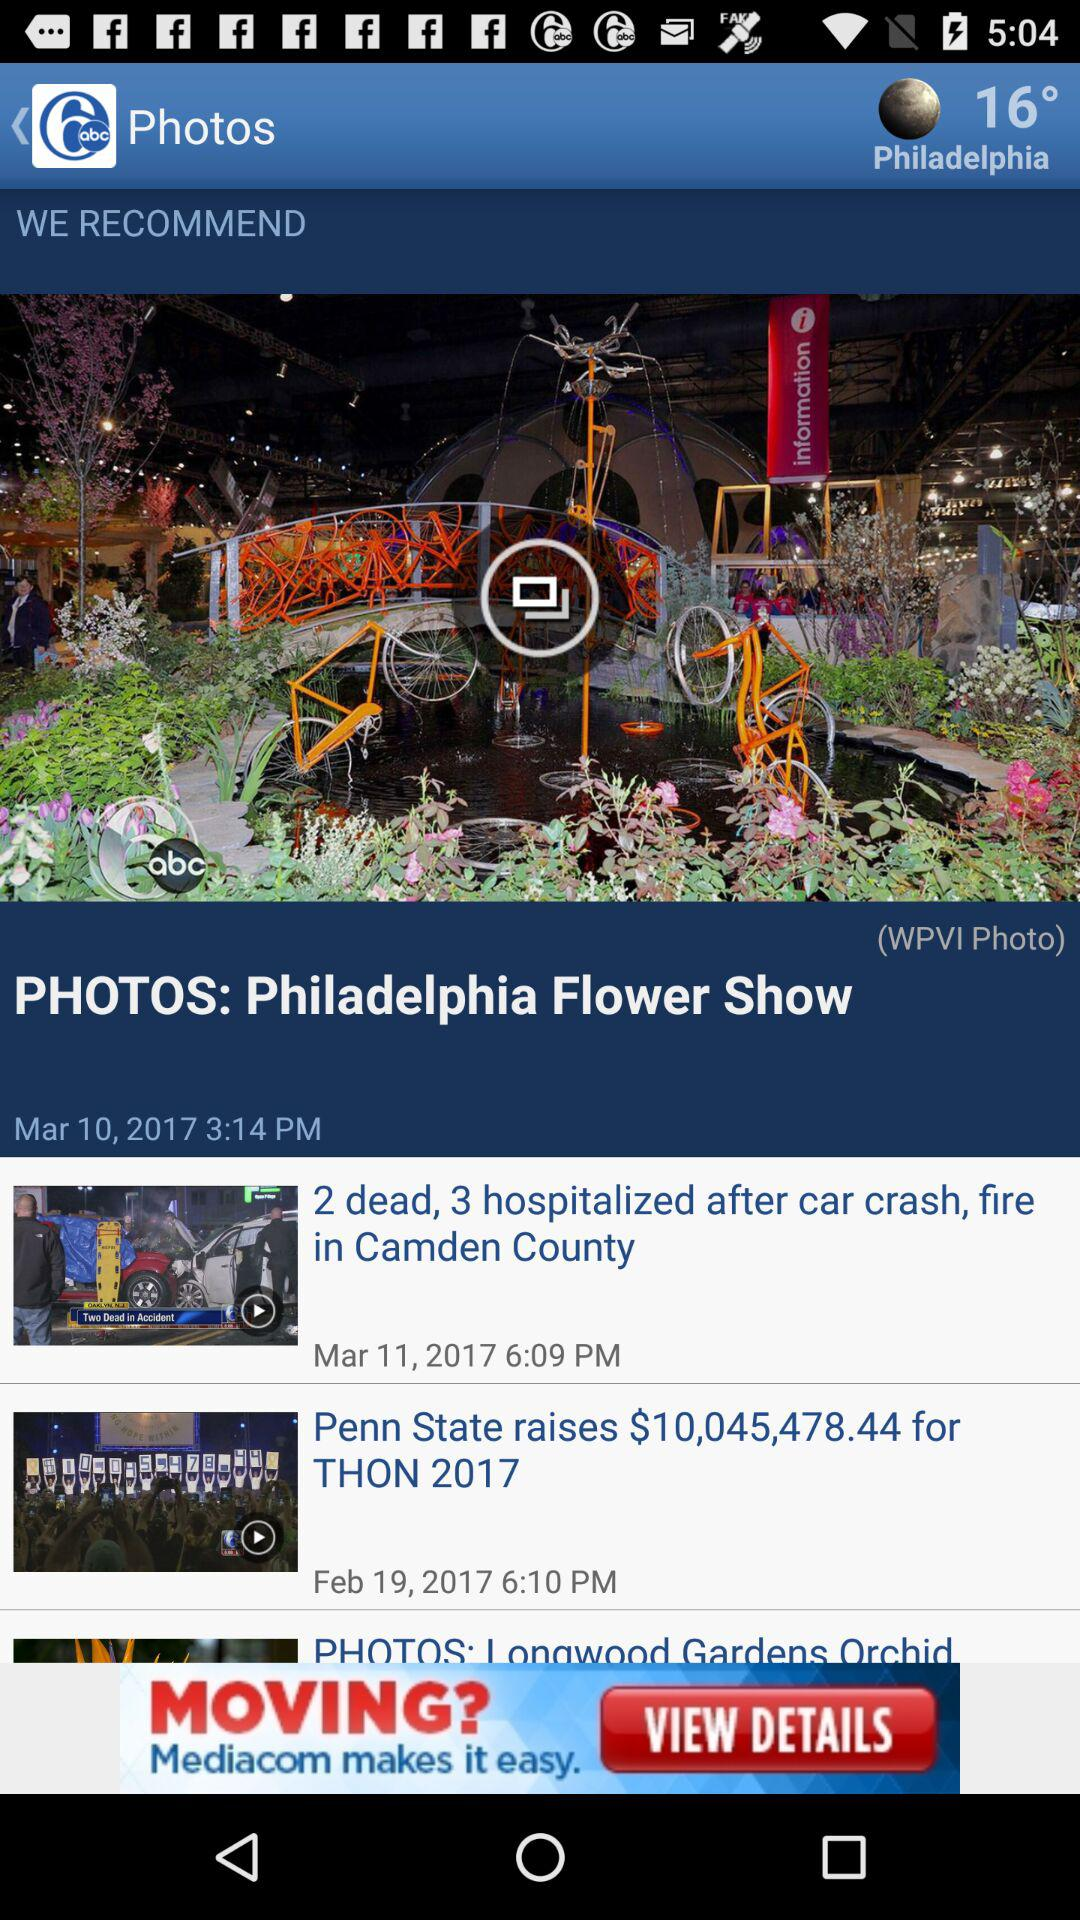What is the name of the person who published "PHOTOS: Philadelphia Flower Show"?
When the provided information is insufficient, respond with <no answer>. <no answer> 